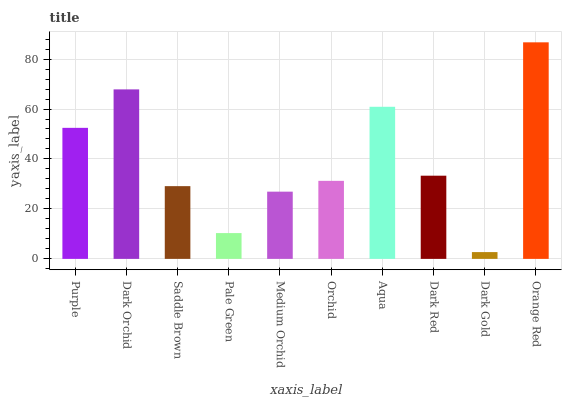Is Dark Gold the minimum?
Answer yes or no. Yes. Is Orange Red the maximum?
Answer yes or no. Yes. Is Dark Orchid the minimum?
Answer yes or no. No. Is Dark Orchid the maximum?
Answer yes or no. No. Is Dark Orchid greater than Purple?
Answer yes or no. Yes. Is Purple less than Dark Orchid?
Answer yes or no. Yes. Is Purple greater than Dark Orchid?
Answer yes or no. No. Is Dark Orchid less than Purple?
Answer yes or no. No. Is Dark Red the high median?
Answer yes or no. Yes. Is Orchid the low median?
Answer yes or no. Yes. Is Dark Orchid the high median?
Answer yes or no. No. Is Dark Red the low median?
Answer yes or no. No. 